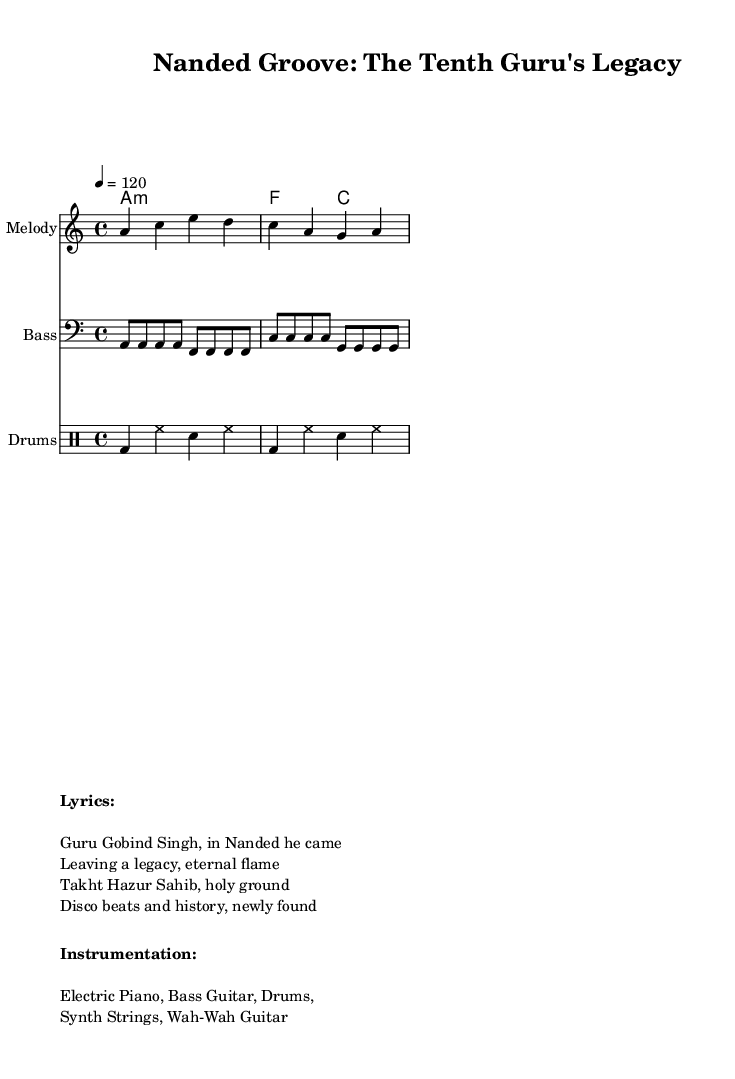What is the key signature of this music? The key signature is A minor, which has no sharps or flats noted in the score. It is indicated at the beginning of the global music context.
Answer: A minor What is the time signature of this music? The time signature is 4/4, as shown in the global settings of the score, indicating that there are four beats per measure.
Answer: 4/4 What is the tempo marking for this piece? The tempo marking is 120 beats per minute, indicated in the global section of the score with the notation "4 = 120." This means the quarter note is equal to 120 beats per minute.
Answer: 120 Which instrument plays the melody? The melody is played by the instrument labelled "Melody" in the score. This means the staff specifically designated for the melody part is where the notes for this instrument are written.
Answer: Melody What are the main instruments used in this piece? The main instruments listed in the instrumentation section are Electric Piano, Bass Guitar, Drums, Synth Strings, and Wah-Wah Guitar. This information is provided in the markup section of the score under "Instrumentation."
Answer: Electric Piano, Bass Guitar, Drums, Synth Strings, Wah-Wah Guitar What musical genre does this piece belong to? This piece belongs to the Disco genre, as indicated by the title "Nanded Groove: The Tenth Guru's Legacy," which suggests a funk-infused disco style throughout the music.
Answer: Disco 